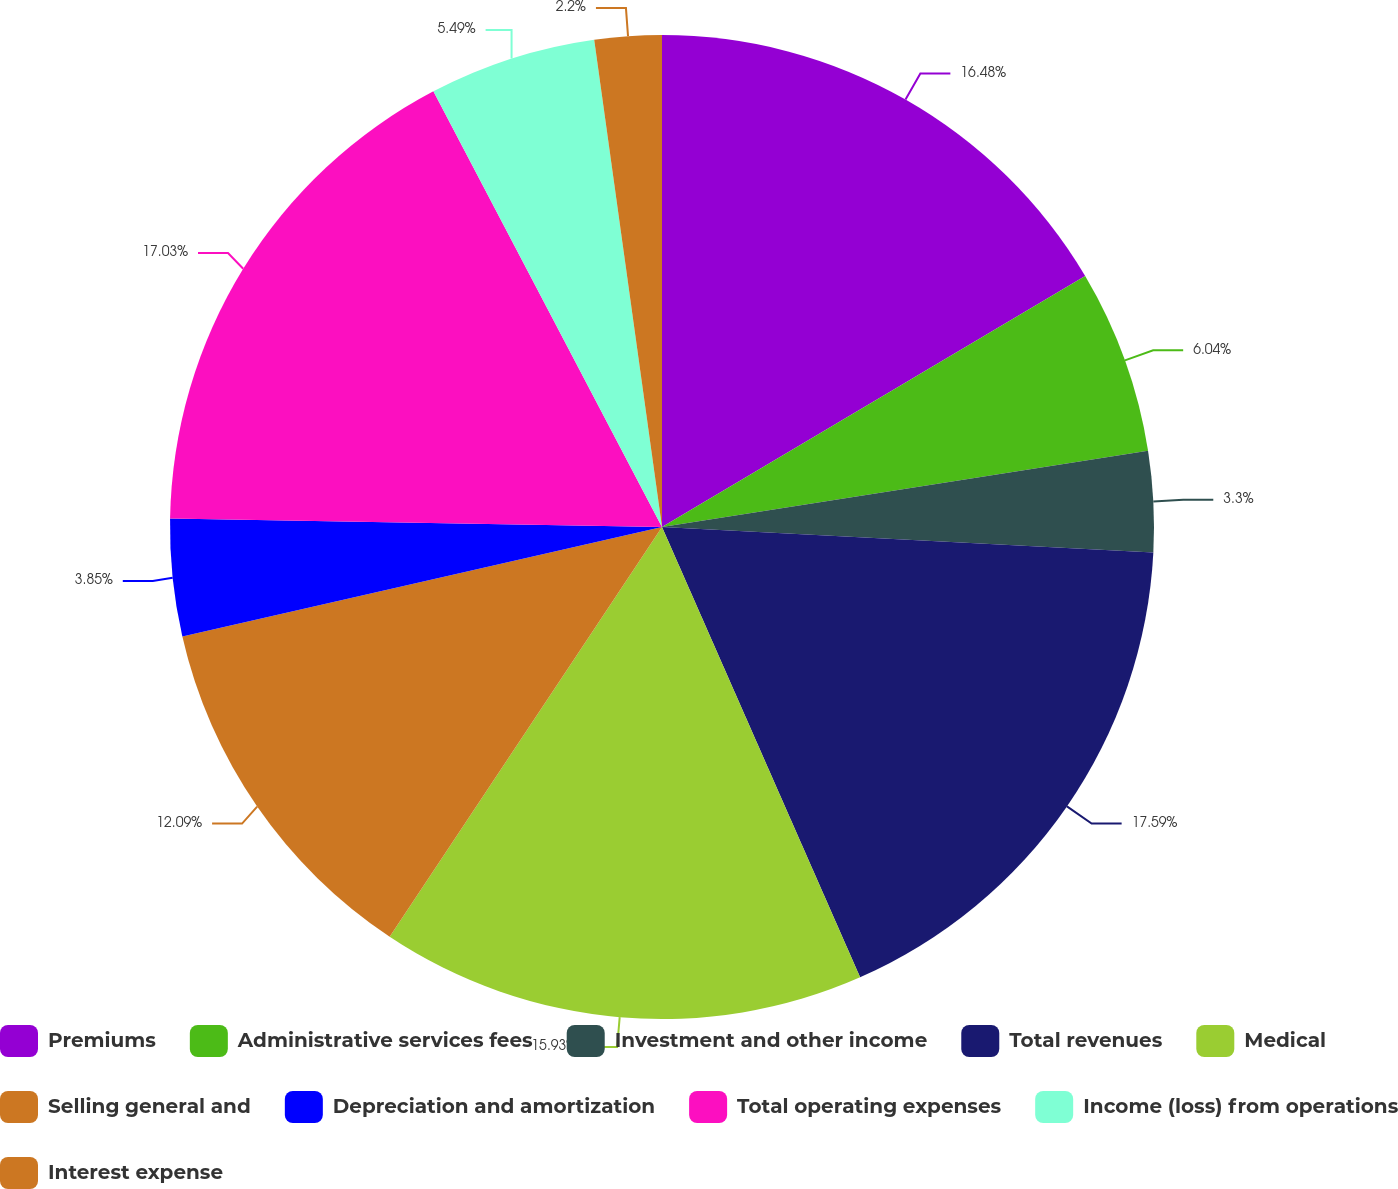<chart> <loc_0><loc_0><loc_500><loc_500><pie_chart><fcel>Premiums<fcel>Administrative services fees<fcel>Investment and other income<fcel>Total revenues<fcel>Medical<fcel>Selling general and<fcel>Depreciation and amortization<fcel>Total operating expenses<fcel>Income (loss) from operations<fcel>Interest expense<nl><fcel>16.48%<fcel>6.04%<fcel>3.3%<fcel>17.58%<fcel>15.93%<fcel>12.09%<fcel>3.85%<fcel>17.03%<fcel>5.49%<fcel>2.2%<nl></chart> 